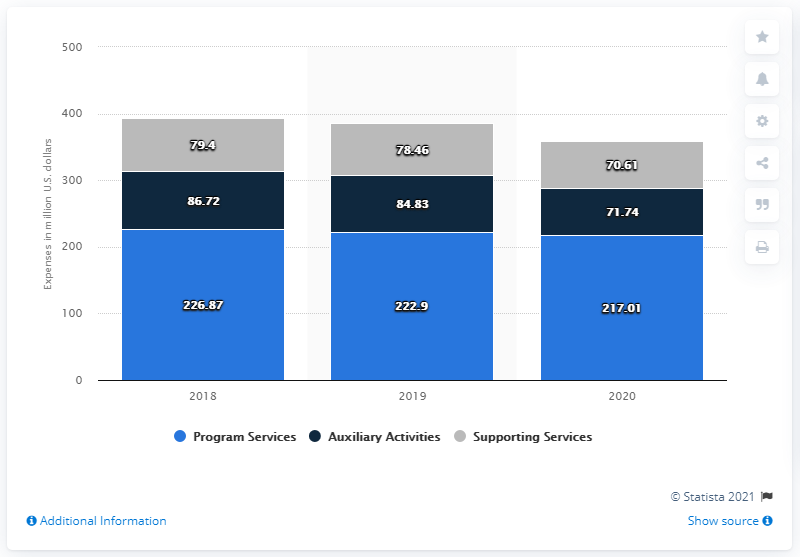Draw attention to some important aspects in this diagram. In 2020, the Metropolitan Museum of Art's auxiliary expenses amounted to $71.74 million. The difference between the shortest light blue bar and the tallest grey bar is 137.61. The Program Services expenses of the Metropolitan Museum of Art from 2018 to 2020 were approximately $217.01 million. The sum of all supporting services expenses across all years is greater than the program services expense in 2018. 